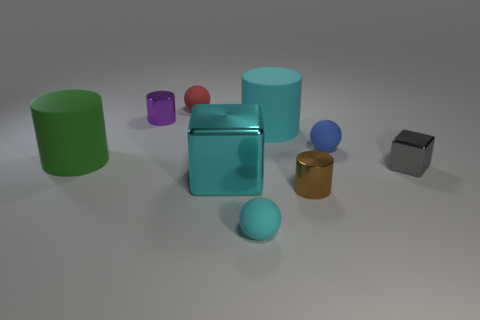Subtract all balls. How many objects are left? 6 Add 5 large green rubber things. How many large green rubber things are left? 6 Add 6 big green cylinders. How many big green cylinders exist? 7 Subtract 0 red blocks. How many objects are left? 9 Subtract all tiny red matte objects. Subtract all tiny rubber spheres. How many objects are left? 5 